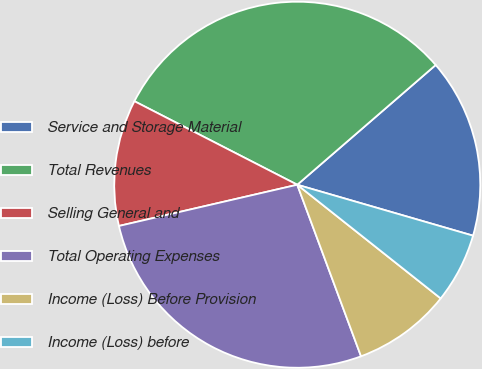Convert chart. <chart><loc_0><loc_0><loc_500><loc_500><pie_chart><fcel>Service and Storage Material<fcel>Total Revenues<fcel>Selling General and<fcel>Total Operating Expenses<fcel>Income (Loss) Before Provision<fcel>Income (Loss) before<nl><fcel>15.84%<fcel>31.11%<fcel>11.16%<fcel>27.05%<fcel>8.67%<fcel>6.18%<nl></chart> 